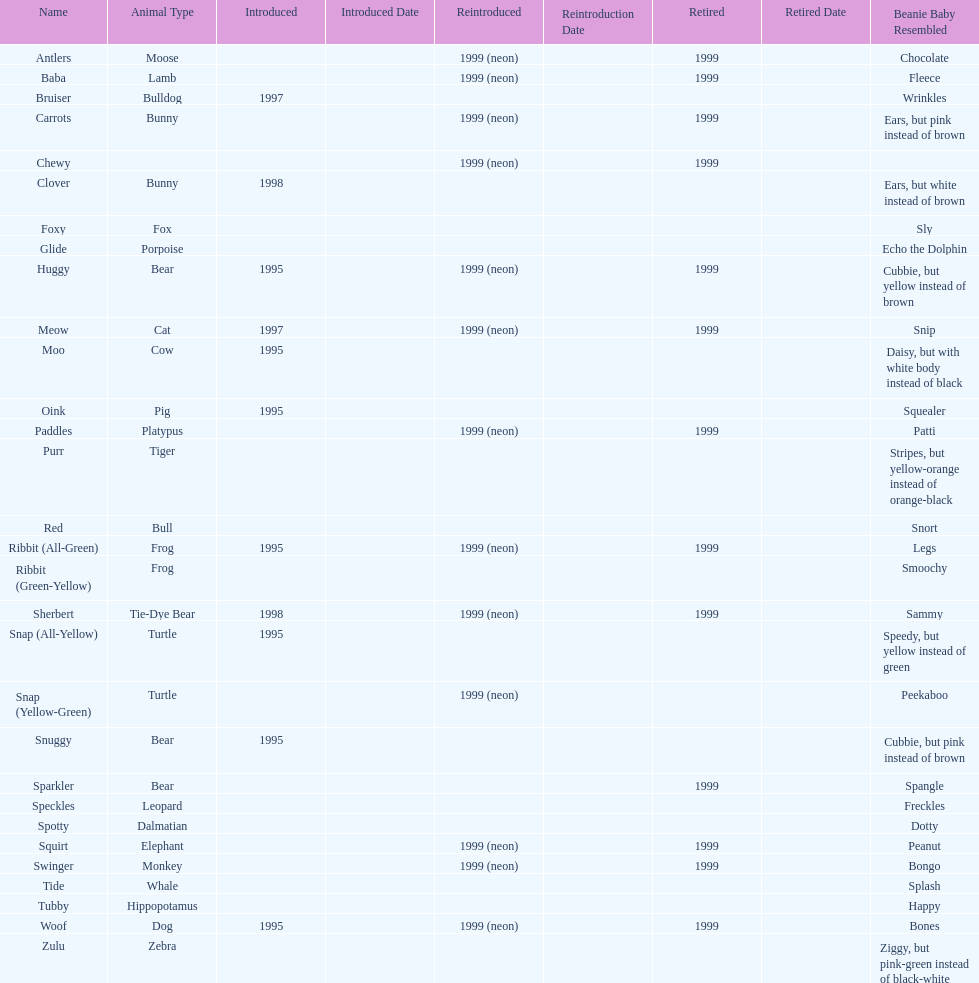What is the name of the last pillow pal on this chart? Zulu. 